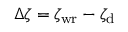Convert formula to latex. <formula><loc_0><loc_0><loc_500><loc_500>\Delta \zeta = \zeta _ { w r } - \zeta _ { d }</formula> 